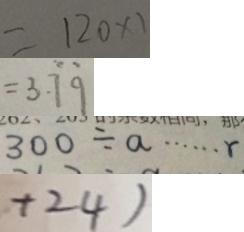<formula> <loc_0><loc_0><loc_500><loc_500>= 1 2 0 \times 1 
 = 3 . \dot { 7 } \dot { 9 } 
 3 0 0 \div a \cdots r 
 + 2 4 )</formula> 